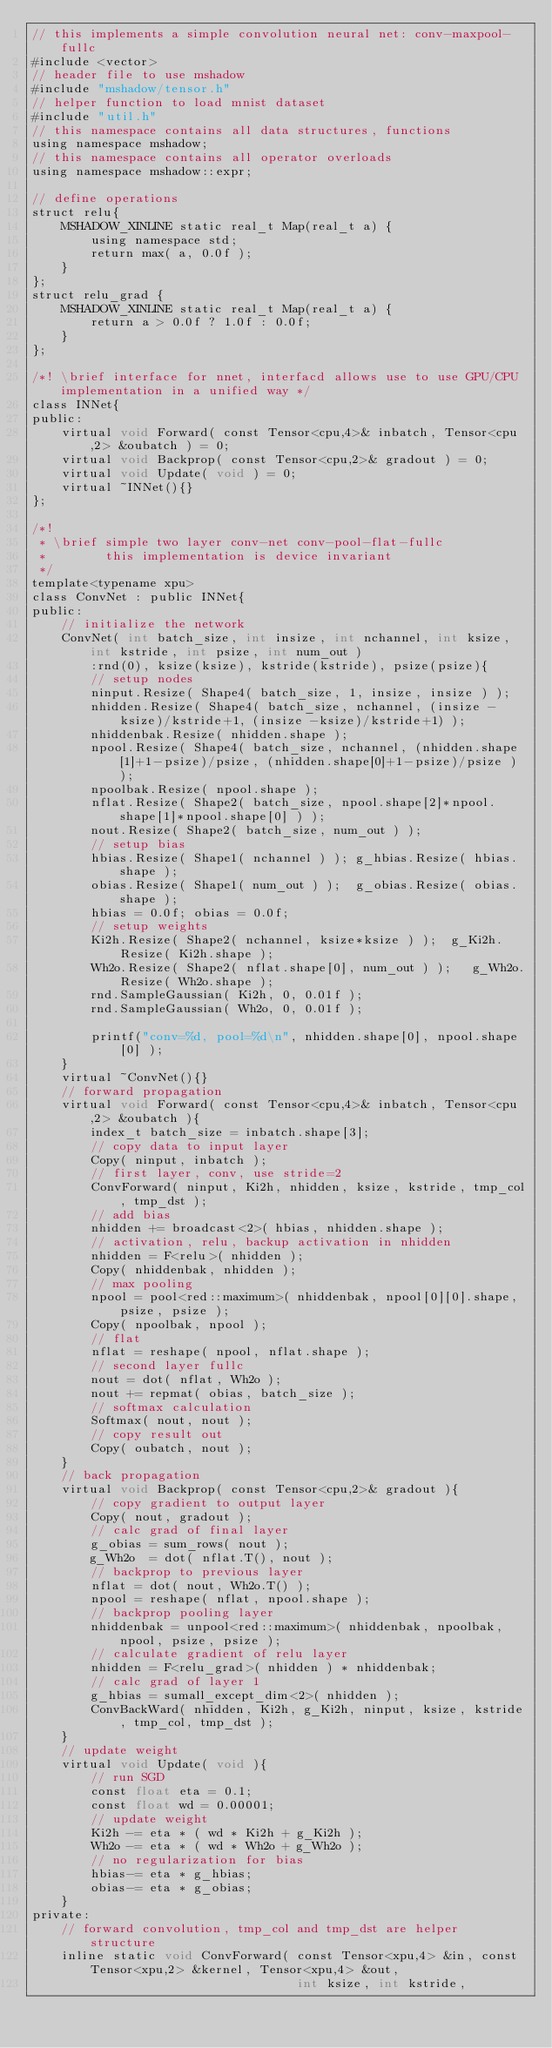Convert code to text. <code><loc_0><loc_0><loc_500><loc_500><_Cuda_>// this implements a simple convolution neural net: conv-maxpool-fullc
#include <vector>
// header file to use mshadow
#include "mshadow/tensor.h"
// helper function to load mnist dataset
#include "util.h"
// this namespace contains all data structures, functions
using namespace mshadow;
// this namespace contains all operator overloads
using namespace mshadow::expr;

// define operations 
struct relu{
    MSHADOW_XINLINE static real_t Map(real_t a) {
        using namespace std;
        return max( a, 0.0f );
    }    
};
struct relu_grad {
    MSHADOW_XINLINE static real_t Map(real_t a) {
        return a > 0.0f ? 1.0f : 0.0f;
    }
};

/*! \brief interface for nnet, interfacd allows use to use GPU/CPU implementation in a unified way */
class INNet{
public:
    virtual void Forward( const Tensor<cpu,4>& inbatch, Tensor<cpu,2> &oubatch ) = 0;
    virtual void Backprop( const Tensor<cpu,2>& gradout ) = 0;    
    virtual void Update( void ) = 0;
    virtual ~INNet(){}
};

/*! 
 * \brief simple two layer conv-net conv-pool-flat-fullc
 *        this implementation is device invariant
 */
template<typename xpu>
class ConvNet : public INNet{
public:
    // initialize the network
    ConvNet( int batch_size, int insize, int nchannel, int ksize, int kstride, int psize, int num_out )
        :rnd(0), ksize(ksize), kstride(kstride), psize(psize){
        // setup nodes
        ninput.Resize( Shape4( batch_size, 1, insize, insize ) );
        nhidden.Resize( Shape4( batch_size, nchannel, (insize - ksize)/kstride+1, (insize -ksize)/kstride+1) ); 
        nhiddenbak.Resize( nhidden.shape );
        npool.Resize( Shape4( batch_size, nchannel, (nhidden.shape[1]+1-psize)/psize, (nhidden.shape[0]+1-psize)/psize ) );
        npoolbak.Resize( npool.shape );
        nflat.Resize( Shape2( batch_size, npool.shape[2]*npool.shape[1]*npool.shape[0] ) );
        nout.Resize( Shape2( batch_size, num_out ) );
        // setup bias
        hbias.Resize( Shape1( nchannel ) ); g_hbias.Resize( hbias.shape );
        obias.Resize( Shape1( num_out ) );  g_obias.Resize( obias.shape );
        hbias = 0.0f; obias = 0.0f;
        // setup weights
        Ki2h.Resize( Shape2( nchannel, ksize*ksize ) );  g_Ki2h.Resize( Ki2h.shape );
        Wh2o.Resize( Shape2( nflat.shape[0], num_out ) );   g_Wh2o.Resize( Wh2o.shape );
        rnd.SampleGaussian( Ki2h, 0, 0.01f );
        rnd.SampleGaussian( Wh2o, 0, 0.01f );

        printf("conv=%d, pool=%d\n", nhidden.shape[0], npool.shape[0] );
    }
    virtual ~ConvNet(){}
    // forward propagation
    virtual void Forward( const Tensor<cpu,4>& inbatch, Tensor<cpu,2> &oubatch ){
        index_t batch_size = inbatch.shape[3];
        // copy data to input layer
        Copy( ninput, inbatch );
        // first layer, conv, use stride=2
        ConvForward( ninput, Ki2h, nhidden, ksize, kstride, tmp_col, tmp_dst );
        // add bias
        nhidden += broadcast<2>( hbias, nhidden.shape );
        // activation, relu, backup activation in nhidden 
        nhidden = F<relu>( nhidden );
        Copy( nhiddenbak, nhidden );
        // max pooling 
        npool = pool<red::maximum>( nhiddenbak, npool[0][0].shape, psize, psize );
        Copy( npoolbak, npool );
        // flat
        nflat = reshape( npool, nflat.shape );
        // second layer fullc
        nout = dot( nflat, Wh2o );
        nout += repmat( obias, batch_size );
        // softmax calculation
        Softmax( nout, nout );
        // copy result out
        Copy( oubatch, nout );
    }
    // back propagation
    virtual void Backprop( const Tensor<cpu,2>& gradout ){        
        // copy gradient to output layer
        Copy( nout, gradout );
        // calc grad of final layer
        g_obias = sum_rows( nout );
        g_Wh2o  = dot( nflat.T(), nout );
        // backprop to previous layer
        nflat = dot( nout, Wh2o.T() );
        npool = reshape( nflat, npool.shape );
        // backprop pooling layer
        nhiddenbak = unpool<red::maximum>( nhiddenbak, npoolbak, npool, psize, psize );        
        // calculate gradient of relu layer
        nhidden = F<relu_grad>( nhidden ) * nhiddenbak;
        // calc grad of layer 1
        g_hbias = sumall_except_dim<2>( nhidden );
        ConvBackWard( nhidden, Ki2h, g_Ki2h, ninput, ksize, kstride, tmp_col, tmp_dst );
    }
    // update weight
    virtual void Update( void ){
        // run SGD
        const float eta = 0.1;
        const float wd = 0.00001;
        // update weight
        Ki2h -= eta * ( wd * Ki2h + g_Ki2h );
        Wh2o -= eta * ( wd * Wh2o + g_Wh2o );
        // no regularization for bias
        hbias-= eta * g_hbias;
        obias-= eta * g_obias;
    }
private:
    // forward convolution, tmp_col and tmp_dst are helper structure 
    inline static void ConvForward( const Tensor<xpu,4> &in, const Tensor<xpu,2> &kernel, Tensor<xpu,4> &out, 
                                    int ksize, int kstride,</code> 